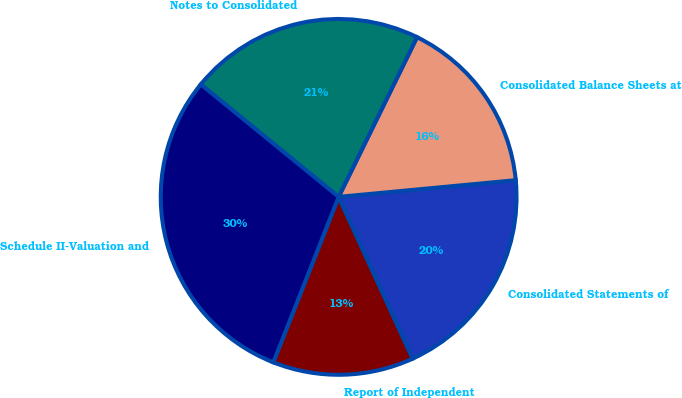Convert chart. <chart><loc_0><loc_0><loc_500><loc_500><pie_chart><fcel>Report of Independent<fcel>Consolidated Statements of<fcel>Consolidated Balance Sheets at<fcel>Notes to Consolidated<fcel>Schedule II-Valuation and<nl><fcel>12.82%<fcel>19.66%<fcel>16.24%<fcel>21.37%<fcel>29.91%<nl></chart> 